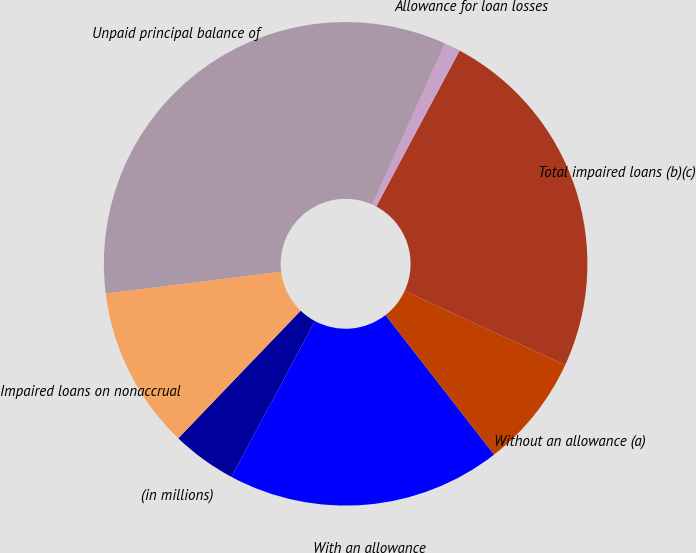<chart> <loc_0><loc_0><loc_500><loc_500><pie_chart><fcel>(in millions)<fcel>With an allowance<fcel>Without an allowance (a)<fcel>Total impaired loans (b)(c)<fcel>Allowance for loan losses<fcel>Unpaid principal balance of<fcel>Impaired loans on nonaccrual<nl><fcel>4.34%<fcel>18.35%<fcel>7.6%<fcel>24.06%<fcel>1.07%<fcel>33.71%<fcel>10.86%<nl></chart> 